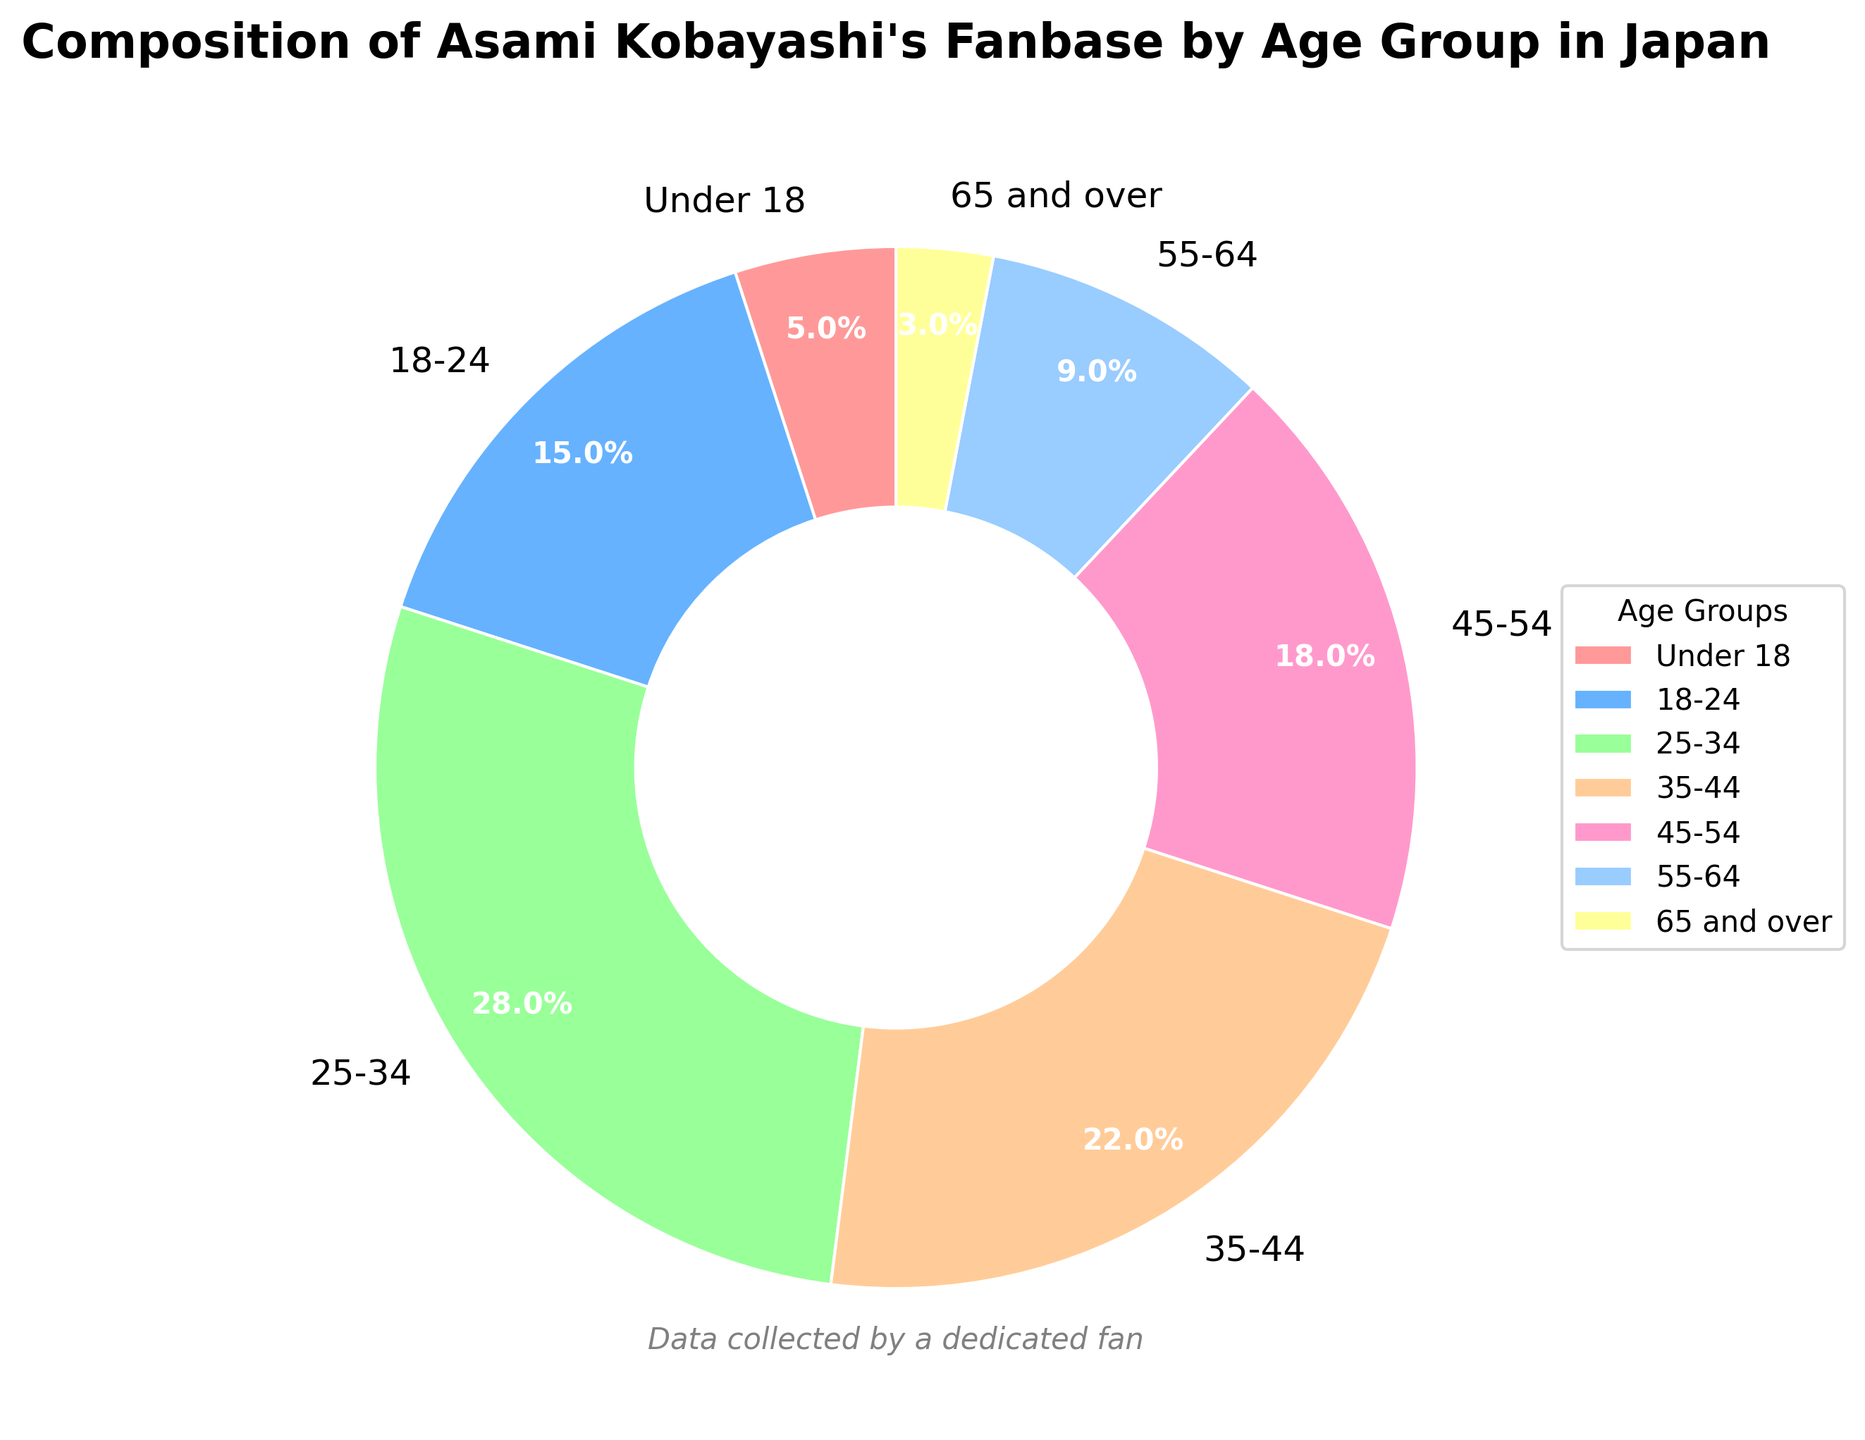What age group makes up the largest proportion of Asami Kobayashi's fanbase? By looking at the pie chart, identify the age group with the largest slice. The "25-34" group has the largest percentage at 28%.
Answer: 25-34 Which age group has a smaller proportion of the fanbase, "Under 18" or "65 and over"? Compare the percentages of the two age groups. "Under 18" comprises 5%, while "65 and over" comprises 3%, so "65 and over" is smaller.
Answer: 65 and over What is the total percentage of fans aged 25 to 44? Add the percentages of the 25-34 and 35-44 age groups: 28% + 22%.
Answer: 50% Are there more fans in the age group 18-24 or in the age group 55-64? Compare the percentages of the 18-24 (15%) and 55-64 (9%) age groups. The 18-24 age group has a higher percentage.
Answer: 18-24 What is the combined percentage of fans who are either under 18 or 65 and over? Add the percentages of the "Under 18" and "65 and over" age groups: 5% + 3%.
Answer: 8% How many age groups have more than 20% of the fanbase? Identify the age groups with percentages higher than 20%. The 25-34 (28%) and 35-44 (22%) groups qualify.
Answer: 2 Which age group has the most visually prominent slice of the pie chart? Visually identify the largest slice. The 25-34 age group with 28% is the most prominent.
Answer: 25-34 What is the difference in percentage between the 18-24 and 45-54 age groups? Subtract the percentage of the 45-54 age group from the 18-24 age group: 15% - 18%.
Answer: 3% What age group has a less than 10% share of the fanbase? Identify the age groups with percentages less than 10%. "Under 18" (5%), "55-64" (9%), and "65 and over" (3%) qualify.
Answer: Under 18, 55-64, 65 and over How does the percentage of fans aged 45-54 compare to those aged 35-44? Compare the percentages of the 45-54 (18%) and 35-44 (22%) age groups. The 35-44 age group has a higher percentage.
Answer: 35-44 